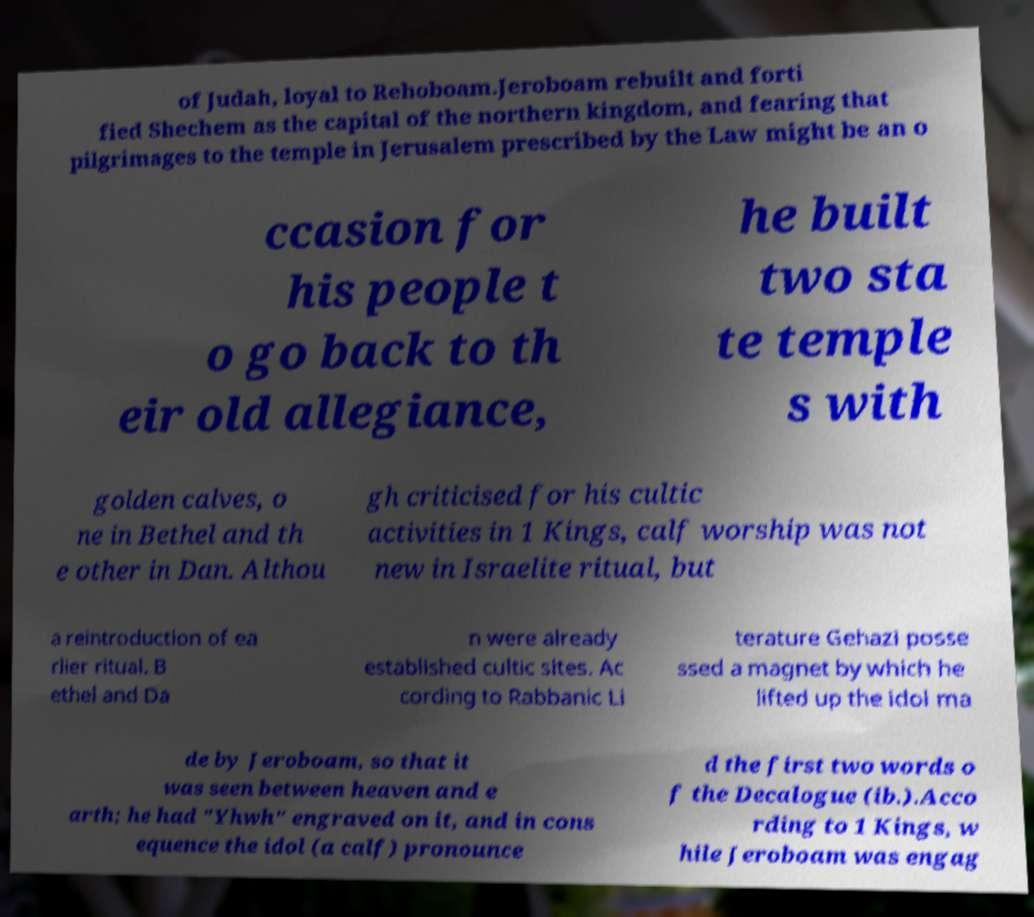There's text embedded in this image that I need extracted. Can you transcribe it verbatim? of Judah, loyal to Rehoboam.Jeroboam rebuilt and forti fied Shechem as the capital of the northern kingdom, and fearing that pilgrimages to the temple in Jerusalem prescribed by the Law might be an o ccasion for his people t o go back to th eir old allegiance, he built two sta te temple s with golden calves, o ne in Bethel and th e other in Dan. Althou gh criticised for his cultic activities in 1 Kings, calf worship was not new in Israelite ritual, but a reintroduction of ea rlier ritual. B ethel and Da n were already established cultic sites. Ac cording to Rabbanic Li terature Gehazi posse ssed a magnet by which he lifted up the idol ma de by Jeroboam, so that it was seen between heaven and e arth; he had "Yhwh" engraved on it, and in cons equence the idol (a calf) pronounce d the first two words o f the Decalogue (ib.).Acco rding to 1 Kings, w hile Jeroboam was engag 